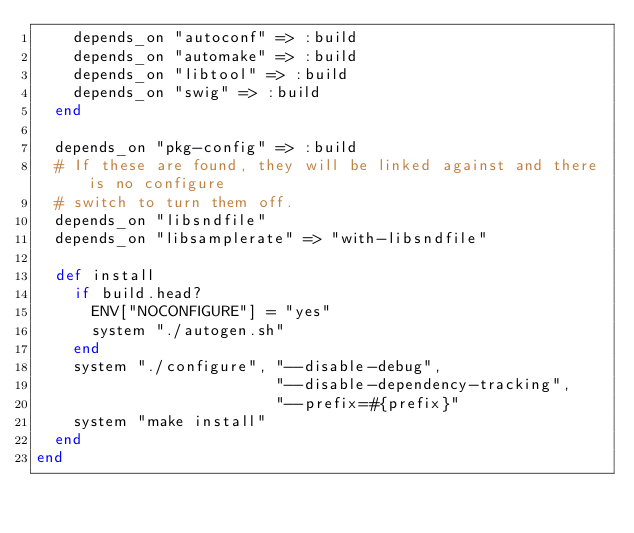<code> <loc_0><loc_0><loc_500><loc_500><_Ruby_>    depends_on "autoconf" => :build
    depends_on "automake" => :build
    depends_on "libtool" => :build
    depends_on "swig" => :build
  end

  depends_on "pkg-config" => :build
  # If these are found, they will be linked against and there is no configure
  # switch to turn them off.
  depends_on "libsndfile"
  depends_on "libsamplerate" => "with-libsndfile"

  def install
    if build.head?
      ENV["NOCONFIGURE"] = "yes"
      system "./autogen.sh"
    end
    system "./configure", "--disable-debug",
                          "--disable-dependency-tracking",
                          "--prefix=#{prefix}"
    system "make install"
  end
end
</code> 